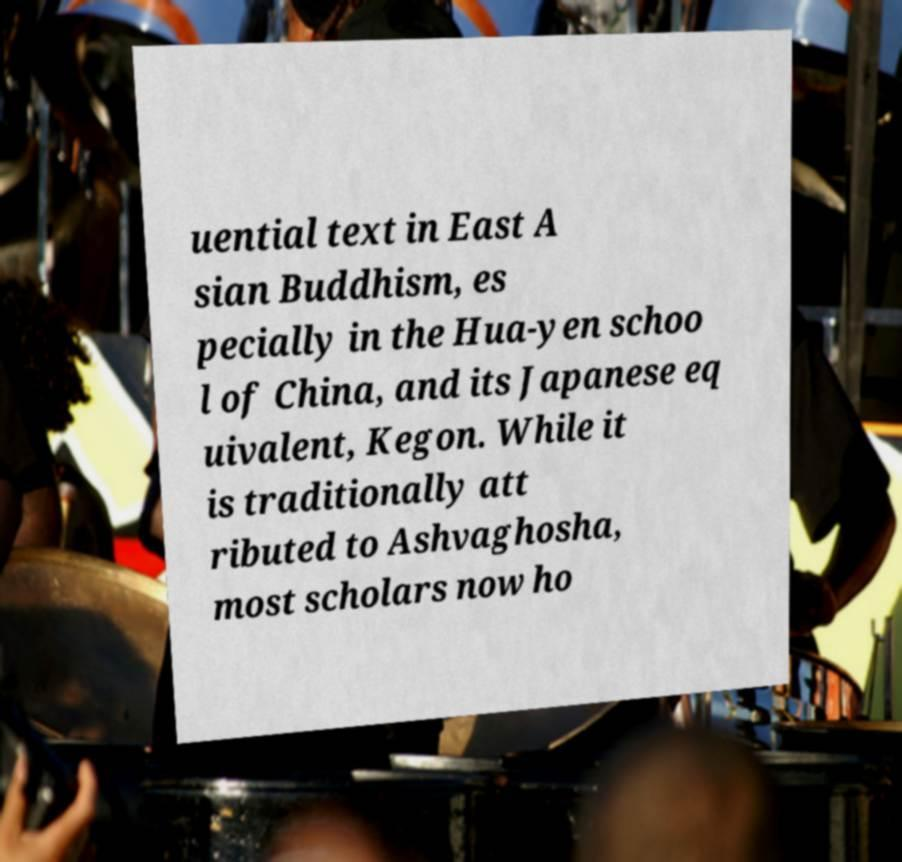What messages or text are displayed in this image? I need them in a readable, typed format. uential text in East A sian Buddhism, es pecially in the Hua-yen schoo l of China, and its Japanese eq uivalent, Kegon. While it is traditionally att ributed to Ashvaghosha, most scholars now ho 